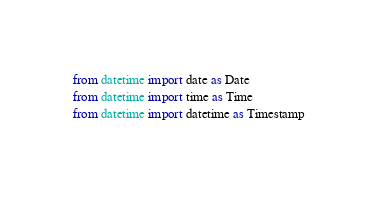<code> <loc_0><loc_0><loc_500><loc_500><_Python_>from datetime import date as Date
from datetime import time as Time
from datetime import datetime as Timestamp</code> 